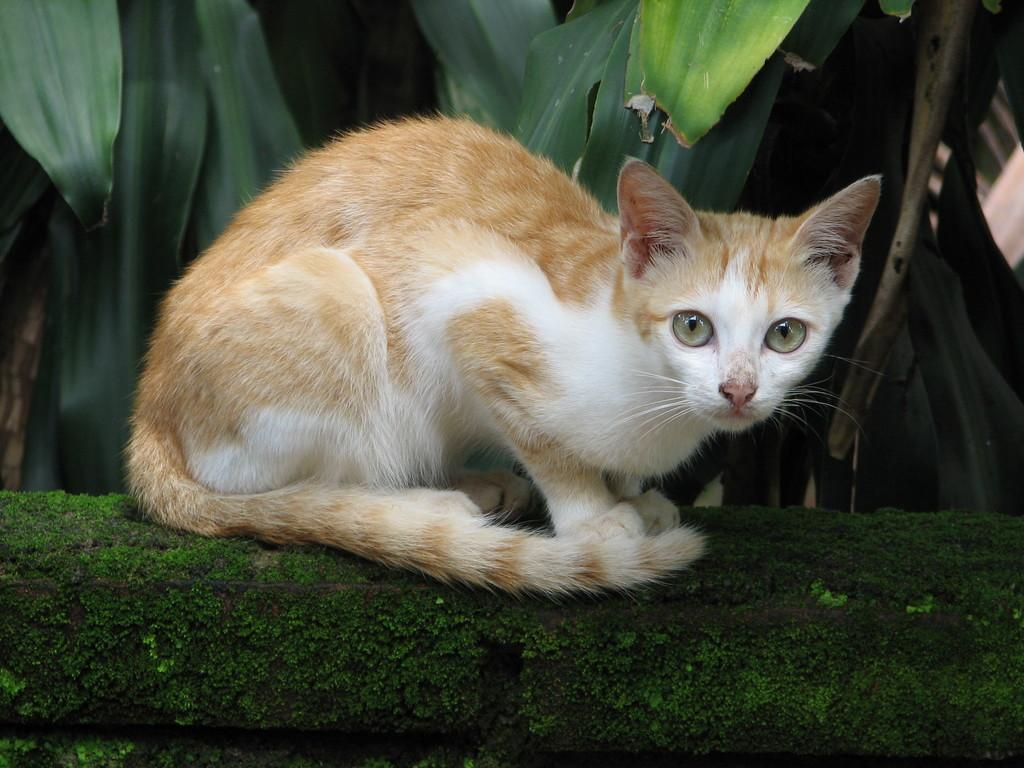What type of animal is sitting in the image? There is a cat sitting in the image. What type of plant life is visible in the image? There is algae visible in the image. What can be seen in the background of the image? There are leaves in the background of the image. What type of hat is the cat wearing in the image? There is no hat present in the image; the cat is not wearing any clothing. 